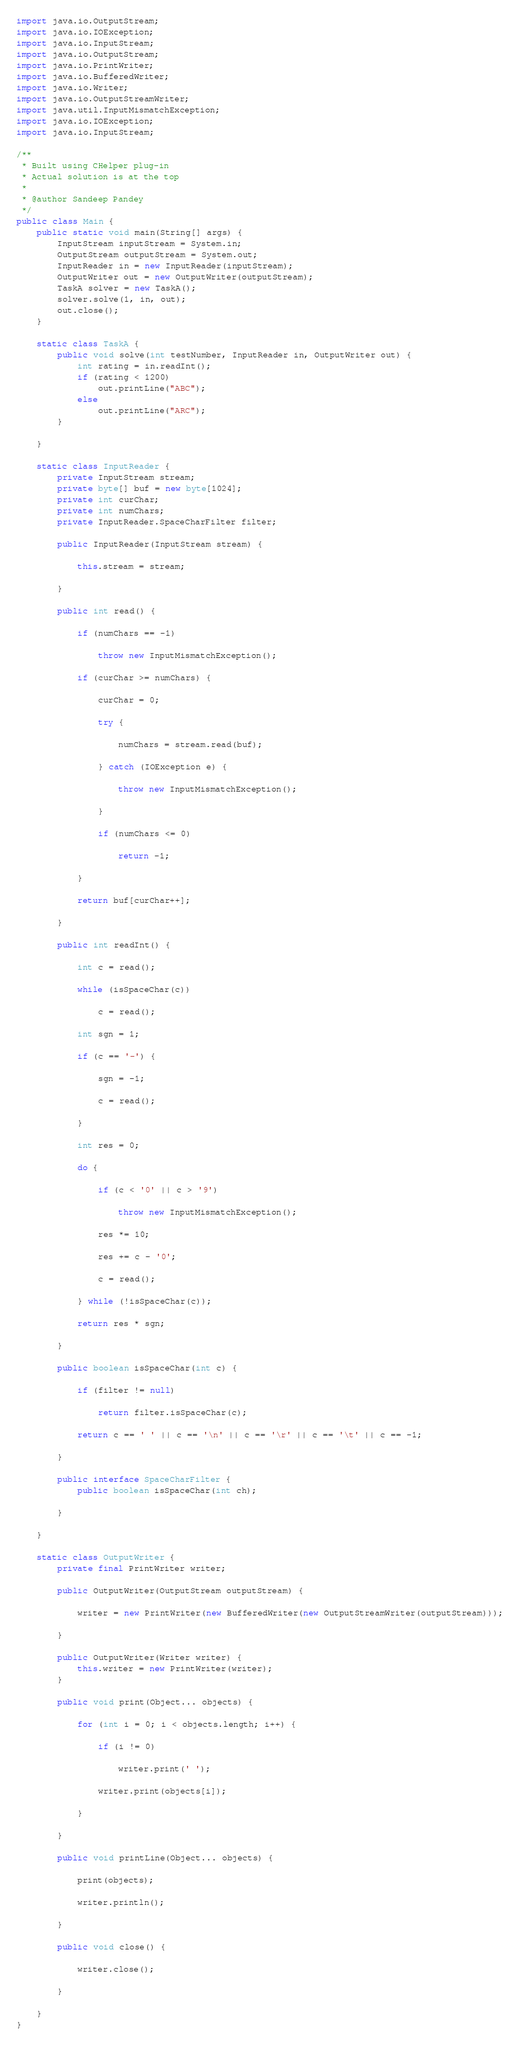Convert code to text. <code><loc_0><loc_0><loc_500><loc_500><_Java_>import java.io.OutputStream;
import java.io.IOException;
import java.io.InputStream;
import java.io.OutputStream;
import java.io.PrintWriter;
import java.io.BufferedWriter;
import java.io.Writer;
import java.io.OutputStreamWriter;
import java.util.InputMismatchException;
import java.io.IOException;
import java.io.InputStream;

/**
 * Built using CHelper plug-in
 * Actual solution is at the top
 *
 * @author Sandeep Pandey
 */
public class Main {
    public static void main(String[] args) {
        InputStream inputStream = System.in;
        OutputStream outputStream = System.out;
        InputReader in = new InputReader(inputStream);
        OutputWriter out = new OutputWriter(outputStream);
        TaskA solver = new TaskA();
        solver.solve(1, in, out);
        out.close();
    }

    static class TaskA {
        public void solve(int testNumber, InputReader in, OutputWriter out) {
            int rating = in.readInt();
            if (rating < 1200)
                out.printLine("ABC");
            else
                out.printLine("ARC");
        }

    }

    static class InputReader {
        private InputStream stream;
        private byte[] buf = new byte[1024];
        private int curChar;
        private int numChars;
        private InputReader.SpaceCharFilter filter;

        public InputReader(InputStream stream) {

            this.stream = stream;

        }

        public int read() {

            if (numChars == -1)

                throw new InputMismatchException();

            if (curChar >= numChars) {

                curChar = 0;

                try {

                    numChars = stream.read(buf);

                } catch (IOException e) {

                    throw new InputMismatchException();

                }

                if (numChars <= 0)

                    return -1;

            }

            return buf[curChar++];

        }

        public int readInt() {

            int c = read();

            while (isSpaceChar(c))

                c = read();

            int sgn = 1;

            if (c == '-') {

                sgn = -1;

                c = read();

            }

            int res = 0;

            do {

                if (c < '0' || c > '9')

                    throw new InputMismatchException();

                res *= 10;

                res += c - '0';

                c = read();

            } while (!isSpaceChar(c));

            return res * sgn;

        }

        public boolean isSpaceChar(int c) {

            if (filter != null)

                return filter.isSpaceChar(c);

            return c == ' ' || c == '\n' || c == '\r' || c == '\t' || c == -1;

        }

        public interface SpaceCharFilter {
            public boolean isSpaceChar(int ch);

        }

    }

    static class OutputWriter {
        private final PrintWriter writer;

        public OutputWriter(OutputStream outputStream) {

            writer = new PrintWriter(new BufferedWriter(new OutputStreamWriter(outputStream)));

        }

        public OutputWriter(Writer writer) {
            this.writer = new PrintWriter(writer);
        }

        public void print(Object... objects) {

            for (int i = 0; i < objects.length; i++) {

                if (i != 0)

                    writer.print(' ');

                writer.print(objects[i]);

            }

        }

        public void printLine(Object... objects) {

            print(objects);

            writer.println();

        }

        public void close() {

            writer.close();

        }

    }
}

</code> 